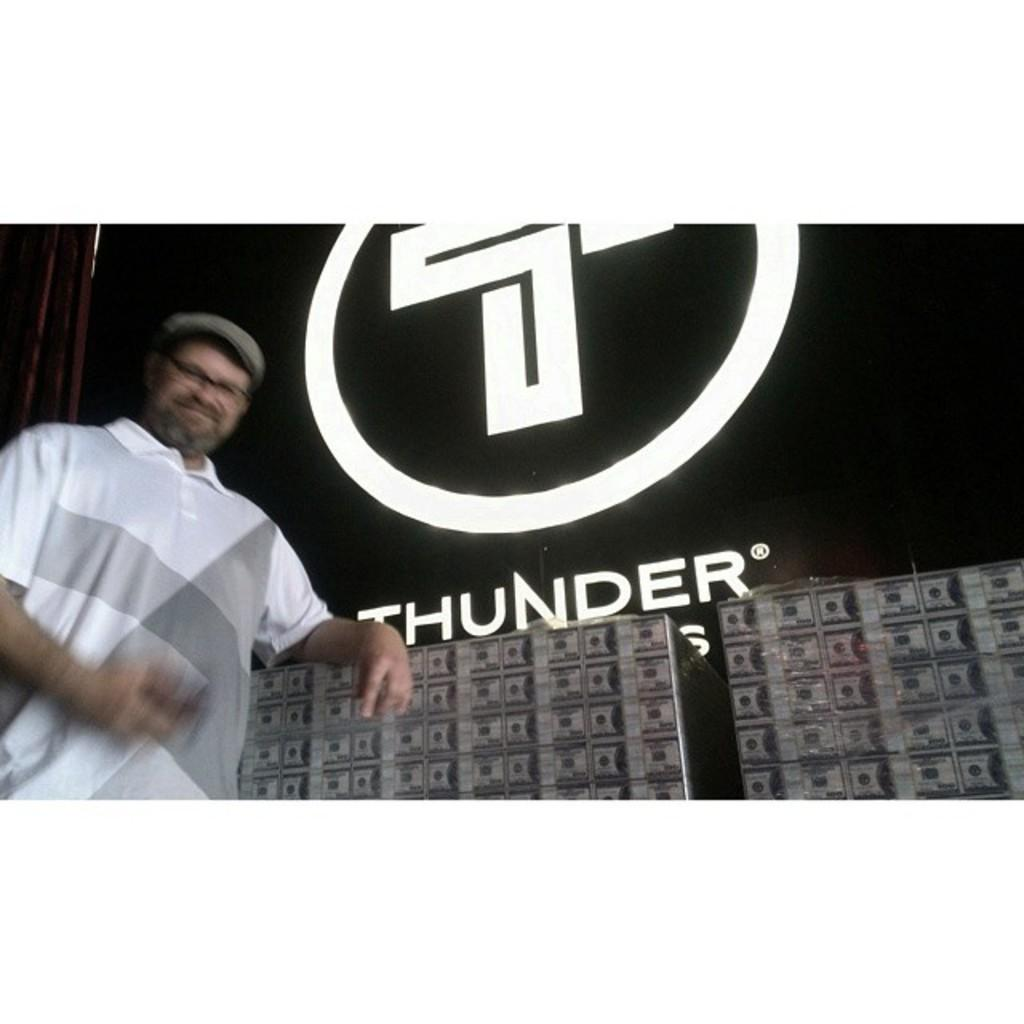Who is on the left side of the image? There is a man on the left side of the image. What is the man wearing? The man is wearing a white t-shirt. What is the man's expression in the image? The man is smiling. What can be seen on the right side of the image? There is a name that is lighting on the right side of the image. How many police officers are present in the image? There are no police officers present in the image. What type of sink can be seen in the image? There is no sink present in the image. 